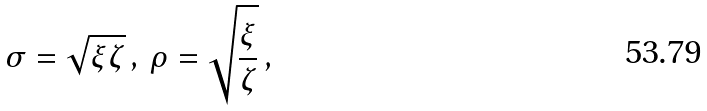Convert formula to latex. <formula><loc_0><loc_0><loc_500><loc_500>\sigma = \sqrt { \xi \zeta } \, , \, \rho = \sqrt { \frac { \xi } { \zeta } } \, ,</formula> 